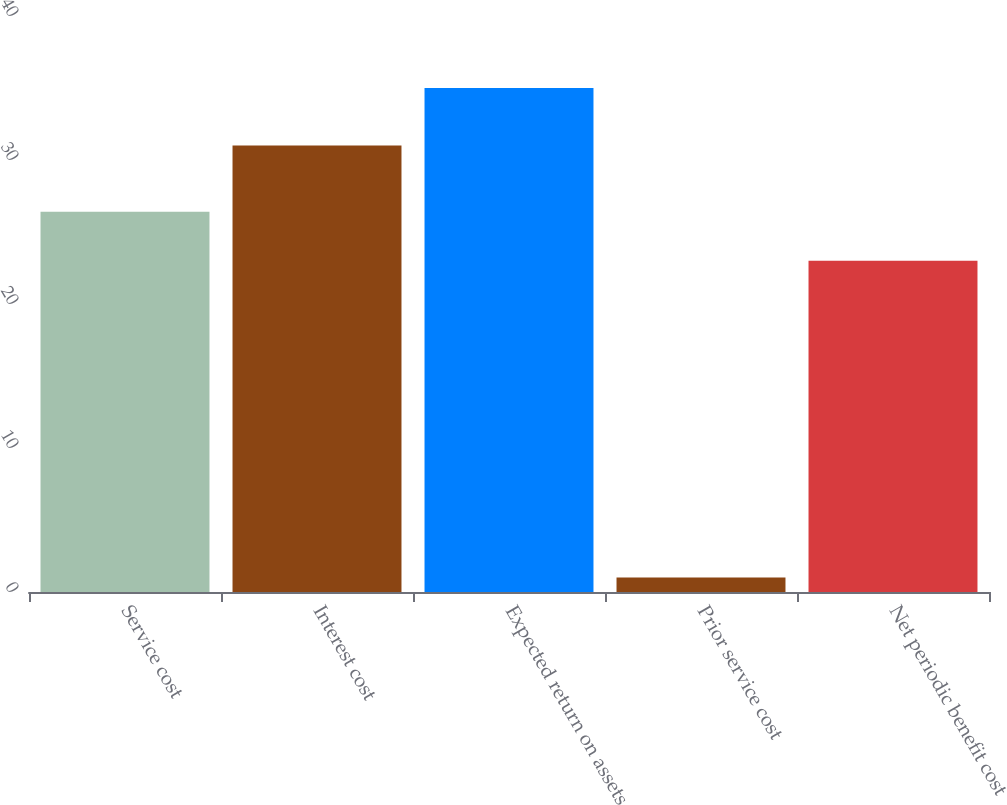<chart> <loc_0><loc_0><loc_500><loc_500><bar_chart><fcel>Service cost<fcel>Interest cost<fcel>Expected return on assets<fcel>Prior service cost<fcel>Net periodic benefit cost<nl><fcel>26.4<fcel>31<fcel>35<fcel>1<fcel>23<nl></chart> 